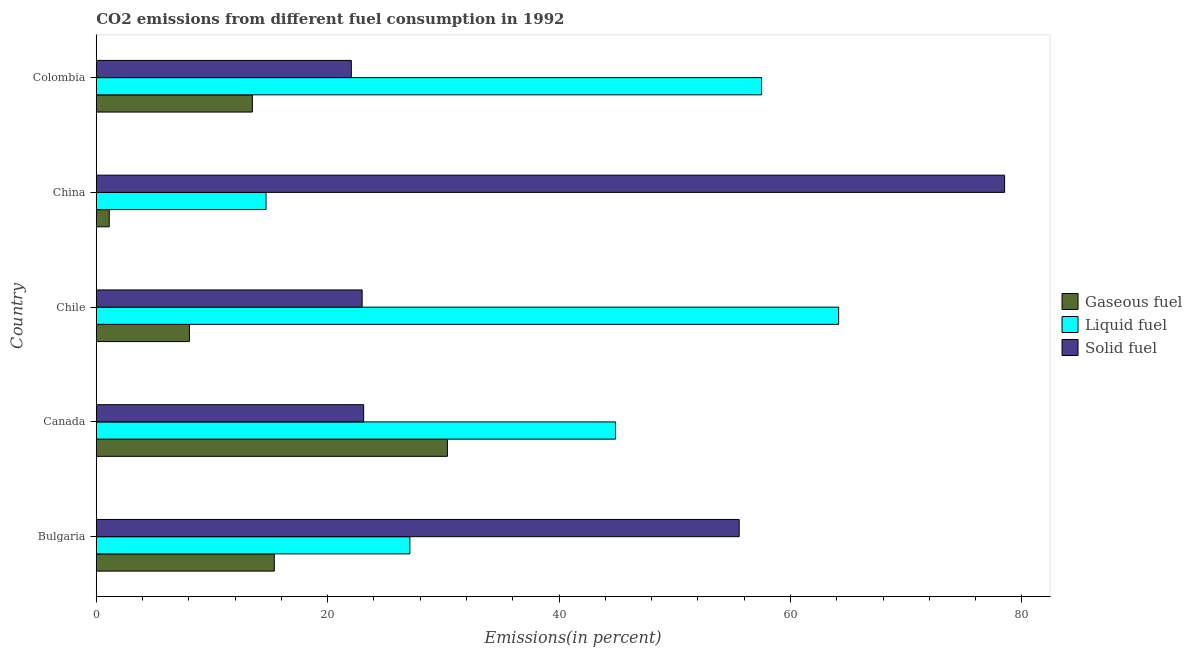How many different coloured bars are there?
Your response must be concise. 3. How many groups of bars are there?
Give a very brief answer. 5. Are the number of bars on each tick of the Y-axis equal?
Provide a succinct answer. Yes. How many bars are there on the 3rd tick from the bottom?
Your answer should be compact. 3. In how many cases, is the number of bars for a given country not equal to the number of legend labels?
Offer a terse response. 0. What is the percentage of liquid fuel emission in Chile?
Make the answer very short. 64.16. Across all countries, what is the maximum percentage of solid fuel emission?
Give a very brief answer. 78.5. Across all countries, what is the minimum percentage of liquid fuel emission?
Provide a succinct answer. 14.67. What is the total percentage of liquid fuel emission in the graph?
Your answer should be very brief. 208.32. What is the difference between the percentage of gaseous fuel emission in Bulgaria and that in Chile?
Make the answer very short. 7.33. What is the difference between the percentage of liquid fuel emission in Colombia and the percentage of solid fuel emission in Canada?
Your response must be concise. 34.39. What is the average percentage of gaseous fuel emission per country?
Provide a short and direct response. 13.68. What is the difference between the percentage of liquid fuel emission and percentage of gaseous fuel emission in China?
Your response must be concise. 13.55. In how many countries, is the percentage of gaseous fuel emission greater than 68 %?
Your answer should be very brief. 0. What is the ratio of the percentage of gaseous fuel emission in Bulgaria to that in Canada?
Provide a short and direct response. 0.51. Is the percentage of gaseous fuel emission in Bulgaria less than that in Canada?
Provide a short and direct response. Yes. Is the difference between the percentage of gaseous fuel emission in Bulgaria and Colombia greater than the difference between the percentage of liquid fuel emission in Bulgaria and Colombia?
Ensure brevity in your answer.  Yes. What is the difference between the highest and the second highest percentage of liquid fuel emission?
Ensure brevity in your answer.  6.66. What is the difference between the highest and the lowest percentage of solid fuel emission?
Provide a succinct answer. 56.46. In how many countries, is the percentage of solid fuel emission greater than the average percentage of solid fuel emission taken over all countries?
Your response must be concise. 2. What does the 1st bar from the top in Chile represents?
Your answer should be very brief. Solid fuel. What does the 2nd bar from the bottom in China represents?
Ensure brevity in your answer.  Liquid fuel. How many bars are there?
Offer a very short reply. 15. Are all the bars in the graph horizontal?
Provide a succinct answer. Yes. How many countries are there in the graph?
Provide a succinct answer. 5. Does the graph contain any zero values?
Make the answer very short. No. Does the graph contain grids?
Provide a succinct answer. No. How are the legend labels stacked?
Your response must be concise. Vertical. What is the title of the graph?
Ensure brevity in your answer.  CO2 emissions from different fuel consumption in 1992. What is the label or title of the X-axis?
Ensure brevity in your answer.  Emissions(in percent). What is the Emissions(in percent) in Gaseous fuel in Bulgaria?
Your answer should be compact. 15.39. What is the Emissions(in percent) of Liquid fuel in Bulgaria?
Make the answer very short. 27.1. What is the Emissions(in percent) of Solid fuel in Bulgaria?
Ensure brevity in your answer.  55.57. What is the Emissions(in percent) in Gaseous fuel in Canada?
Offer a very short reply. 30.35. What is the Emissions(in percent) in Liquid fuel in Canada?
Give a very brief answer. 44.88. What is the Emissions(in percent) of Solid fuel in Canada?
Make the answer very short. 23.11. What is the Emissions(in percent) in Gaseous fuel in Chile?
Provide a short and direct response. 8.05. What is the Emissions(in percent) of Liquid fuel in Chile?
Your answer should be very brief. 64.16. What is the Emissions(in percent) of Solid fuel in Chile?
Offer a very short reply. 22.98. What is the Emissions(in percent) in Gaseous fuel in China?
Give a very brief answer. 1.12. What is the Emissions(in percent) in Liquid fuel in China?
Ensure brevity in your answer.  14.67. What is the Emissions(in percent) of Solid fuel in China?
Make the answer very short. 78.5. What is the Emissions(in percent) in Gaseous fuel in Colombia?
Offer a terse response. 13.49. What is the Emissions(in percent) in Liquid fuel in Colombia?
Give a very brief answer. 57.5. What is the Emissions(in percent) in Solid fuel in Colombia?
Your answer should be very brief. 22.04. Across all countries, what is the maximum Emissions(in percent) of Gaseous fuel?
Your response must be concise. 30.35. Across all countries, what is the maximum Emissions(in percent) in Liquid fuel?
Your response must be concise. 64.16. Across all countries, what is the maximum Emissions(in percent) in Solid fuel?
Your response must be concise. 78.5. Across all countries, what is the minimum Emissions(in percent) of Gaseous fuel?
Your response must be concise. 1.12. Across all countries, what is the minimum Emissions(in percent) of Liquid fuel?
Offer a very short reply. 14.67. Across all countries, what is the minimum Emissions(in percent) in Solid fuel?
Your answer should be compact. 22.04. What is the total Emissions(in percent) in Gaseous fuel in the graph?
Your answer should be very brief. 68.4. What is the total Emissions(in percent) in Liquid fuel in the graph?
Ensure brevity in your answer.  208.32. What is the total Emissions(in percent) of Solid fuel in the graph?
Your answer should be compact. 202.2. What is the difference between the Emissions(in percent) in Gaseous fuel in Bulgaria and that in Canada?
Give a very brief answer. -14.96. What is the difference between the Emissions(in percent) in Liquid fuel in Bulgaria and that in Canada?
Your answer should be very brief. -17.78. What is the difference between the Emissions(in percent) in Solid fuel in Bulgaria and that in Canada?
Your answer should be very brief. 32.46. What is the difference between the Emissions(in percent) of Gaseous fuel in Bulgaria and that in Chile?
Offer a very short reply. 7.34. What is the difference between the Emissions(in percent) in Liquid fuel in Bulgaria and that in Chile?
Your answer should be compact. -37.06. What is the difference between the Emissions(in percent) of Solid fuel in Bulgaria and that in Chile?
Keep it short and to the point. 32.59. What is the difference between the Emissions(in percent) in Gaseous fuel in Bulgaria and that in China?
Offer a terse response. 14.26. What is the difference between the Emissions(in percent) of Liquid fuel in Bulgaria and that in China?
Provide a short and direct response. 12.43. What is the difference between the Emissions(in percent) in Solid fuel in Bulgaria and that in China?
Give a very brief answer. -22.94. What is the difference between the Emissions(in percent) of Gaseous fuel in Bulgaria and that in Colombia?
Give a very brief answer. 1.89. What is the difference between the Emissions(in percent) of Liquid fuel in Bulgaria and that in Colombia?
Provide a short and direct response. -30.4. What is the difference between the Emissions(in percent) in Solid fuel in Bulgaria and that in Colombia?
Give a very brief answer. 33.52. What is the difference between the Emissions(in percent) in Gaseous fuel in Canada and that in Chile?
Keep it short and to the point. 22.3. What is the difference between the Emissions(in percent) of Liquid fuel in Canada and that in Chile?
Your answer should be very brief. -19.28. What is the difference between the Emissions(in percent) in Solid fuel in Canada and that in Chile?
Offer a terse response. 0.13. What is the difference between the Emissions(in percent) in Gaseous fuel in Canada and that in China?
Your answer should be very brief. 29.23. What is the difference between the Emissions(in percent) of Liquid fuel in Canada and that in China?
Provide a short and direct response. 30.21. What is the difference between the Emissions(in percent) in Solid fuel in Canada and that in China?
Make the answer very short. -55.39. What is the difference between the Emissions(in percent) in Gaseous fuel in Canada and that in Colombia?
Your answer should be very brief. 16.86. What is the difference between the Emissions(in percent) in Liquid fuel in Canada and that in Colombia?
Your response must be concise. -12.62. What is the difference between the Emissions(in percent) of Solid fuel in Canada and that in Colombia?
Keep it short and to the point. 1.07. What is the difference between the Emissions(in percent) of Gaseous fuel in Chile and that in China?
Your answer should be very brief. 6.93. What is the difference between the Emissions(in percent) of Liquid fuel in Chile and that in China?
Provide a short and direct response. 49.49. What is the difference between the Emissions(in percent) of Solid fuel in Chile and that in China?
Your response must be concise. -55.53. What is the difference between the Emissions(in percent) of Gaseous fuel in Chile and that in Colombia?
Provide a succinct answer. -5.44. What is the difference between the Emissions(in percent) in Liquid fuel in Chile and that in Colombia?
Provide a short and direct response. 6.66. What is the difference between the Emissions(in percent) in Solid fuel in Chile and that in Colombia?
Provide a succinct answer. 0.94. What is the difference between the Emissions(in percent) of Gaseous fuel in China and that in Colombia?
Offer a terse response. -12.37. What is the difference between the Emissions(in percent) in Liquid fuel in China and that in Colombia?
Make the answer very short. -42.83. What is the difference between the Emissions(in percent) in Solid fuel in China and that in Colombia?
Ensure brevity in your answer.  56.46. What is the difference between the Emissions(in percent) of Gaseous fuel in Bulgaria and the Emissions(in percent) of Liquid fuel in Canada?
Give a very brief answer. -29.5. What is the difference between the Emissions(in percent) of Gaseous fuel in Bulgaria and the Emissions(in percent) of Solid fuel in Canada?
Offer a very short reply. -7.72. What is the difference between the Emissions(in percent) of Liquid fuel in Bulgaria and the Emissions(in percent) of Solid fuel in Canada?
Ensure brevity in your answer.  3.99. What is the difference between the Emissions(in percent) in Gaseous fuel in Bulgaria and the Emissions(in percent) in Liquid fuel in Chile?
Give a very brief answer. -48.77. What is the difference between the Emissions(in percent) in Gaseous fuel in Bulgaria and the Emissions(in percent) in Solid fuel in Chile?
Make the answer very short. -7.59. What is the difference between the Emissions(in percent) of Liquid fuel in Bulgaria and the Emissions(in percent) of Solid fuel in Chile?
Provide a succinct answer. 4.12. What is the difference between the Emissions(in percent) of Gaseous fuel in Bulgaria and the Emissions(in percent) of Liquid fuel in China?
Offer a terse response. 0.71. What is the difference between the Emissions(in percent) of Gaseous fuel in Bulgaria and the Emissions(in percent) of Solid fuel in China?
Offer a very short reply. -63.12. What is the difference between the Emissions(in percent) of Liquid fuel in Bulgaria and the Emissions(in percent) of Solid fuel in China?
Offer a terse response. -51.4. What is the difference between the Emissions(in percent) of Gaseous fuel in Bulgaria and the Emissions(in percent) of Liquid fuel in Colombia?
Your answer should be very brief. -42.12. What is the difference between the Emissions(in percent) in Gaseous fuel in Bulgaria and the Emissions(in percent) in Solid fuel in Colombia?
Offer a very short reply. -6.66. What is the difference between the Emissions(in percent) in Liquid fuel in Bulgaria and the Emissions(in percent) in Solid fuel in Colombia?
Provide a succinct answer. 5.06. What is the difference between the Emissions(in percent) in Gaseous fuel in Canada and the Emissions(in percent) in Liquid fuel in Chile?
Your answer should be very brief. -33.81. What is the difference between the Emissions(in percent) in Gaseous fuel in Canada and the Emissions(in percent) in Solid fuel in Chile?
Offer a very short reply. 7.37. What is the difference between the Emissions(in percent) of Liquid fuel in Canada and the Emissions(in percent) of Solid fuel in Chile?
Keep it short and to the point. 21.9. What is the difference between the Emissions(in percent) in Gaseous fuel in Canada and the Emissions(in percent) in Liquid fuel in China?
Provide a short and direct response. 15.68. What is the difference between the Emissions(in percent) in Gaseous fuel in Canada and the Emissions(in percent) in Solid fuel in China?
Keep it short and to the point. -48.16. What is the difference between the Emissions(in percent) of Liquid fuel in Canada and the Emissions(in percent) of Solid fuel in China?
Your answer should be compact. -33.62. What is the difference between the Emissions(in percent) in Gaseous fuel in Canada and the Emissions(in percent) in Liquid fuel in Colombia?
Offer a terse response. -27.15. What is the difference between the Emissions(in percent) in Gaseous fuel in Canada and the Emissions(in percent) in Solid fuel in Colombia?
Keep it short and to the point. 8.3. What is the difference between the Emissions(in percent) in Liquid fuel in Canada and the Emissions(in percent) in Solid fuel in Colombia?
Ensure brevity in your answer.  22.84. What is the difference between the Emissions(in percent) of Gaseous fuel in Chile and the Emissions(in percent) of Liquid fuel in China?
Keep it short and to the point. -6.62. What is the difference between the Emissions(in percent) of Gaseous fuel in Chile and the Emissions(in percent) of Solid fuel in China?
Your answer should be very brief. -70.45. What is the difference between the Emissions(in percent) in Liquid fuel in Chile and the Emissions(in percent) in Solid fuel in China?
Provide a succinct answer. -14.34. What is the difference between the Emissions(in percent) in Gaseous fuel in Chile and the Emissions(in percent) in Liquid fuel in Colombia?
Your answer should be compact. -49.45. What is the difference between the Emissions(in percent) in Gaseous fuel in Chile and the Emissions(in percent) in Solid fuel in Colombia?
Give a very brief answer. -13.99. What is the difference between the Emissions(in percent) of Liquid fuel in Chile and the Emissions(in percent) of Solid fuel in Colombia?
Your response must be concise. 42.12. What is the difference between the Emissions(in percent) in Gaseous fuel in China and the Emissions(in percent) in Liquid fuel in Colombia?
Ensure brevity in your answer.  -56.38. What is the difference between the Emissions(in percent) of Gaseous fuel in China and the Emissions(in percent) of Solid fuel in Colombia?
Ensure brevity in your answer.  -20.92. What is the difference between the Emissions(in percent) in Liquid fuel in China and the Emissions(in percent) in Solid fuel in Colombia?
Provide a short and direct response. -7.37. What is the average Emissions(in percent) of Gaseous fuel per country?
Offer a terse response. 13.68. What is the average Emissions(in percent) of Liquid fuel per country?
Offer a very short reply. 41.66. What is the average Emissions(in percent) in Solid fuel per country?
Ensure brevity in your answer.  40.44. What is the difference between the Emissions(in percent) of Gaseous fuel and Emissions(in percent) of Liquid fuel in Bulgaria?
Provide a succinct answer. -11.72. What is the difference between the Emissions(in percent) of Gaseous fuel and Emissions(in percent) of Solid fuel in Bulgaria?
Offer a very short reply. -40.18. What is the difference between the Emissions(in percent) of Liquid fuel and Emissions(in percent) of Solid fuel in Bulgaria?
Provide a short and direct response. -28.46. What is the difference between the Emissions(in percent) of Gaseous fuel and Emissions(in percent) of Liquid fuel in Canada?
Provide a short and direct response. -14.54. What is the difference between the Emissions(in percent) in Gaseous fuel and Emissions(in percent) in Solid fuel in Canada?
Provide a succinct answer. 7.24. What is the difference between the Emissions(in percent) in Liquid fuel and Emissions(in percent) in Solid fuel in Canada?
Offer a terse response. 21.77. What is the difference between the Emissions(in percent) in Gaseous fuel and Emissions(in percent) in Liquid fuel in Chile?
Your answer should be compact. -56.11. What is the difference between the Emissions(in percent) of Gaseous fuel and Emissions(in percent) of Solid fuel in Chile?
Your response must be concise. -14.93. What is the difference between the Emissions(in percent) of Liquid fuel and Emissions(in percent) of Solid fuel in Chile?
Make the answer very short. 41.18. What is the difference between the Emissions(in percent) in Gaseous fuel and Emissions(in percent) in Liquid fuel in China?
Provide a short and direct response. -13.55. What is the difference between the Emissions(in percent) of Gaseous fuel and Emissions(in percent) of Solid fuel in China?
Your response must be concise. -77.38. What is the difference between the Emissions(in percent) in Liquid fuel and Emissions(in percent) in Solid fuel in China?
Provide a succinct answer. -63.83. What is the difference between the Emissions(in percent) of Gaseous fuel and Emissions(in percent) of Liquid fuel in Colombia?
Keep it short and to the point. -44.01. What is the difference between the Emissions(in percent) of Gaseous fuel and Emissions(in percent) of Solid fuel in Colombia?
Ensure brevity in your answer.  -8.55. What is the difference between the Emissions(in percent) of Liquid fuel and Emissions(in percent) of Solid fuel in Colombia?
Give a very brief answer. 35.46. What is the ratio of the Emissions(in percent) in Gaseous fuel in Bulgaria to that in Canada?
Give a very brief answer. 0.51. What is the ratio of the Emissions(in percent) in Liquid fuel in Bulgaria to that in Canada?
Your answer should be very brief. 0.6. What is the ratio of the Emissions(in percent) of Solid fuel in Bulgaria to that in Canada?
Your answer should be very brief. 2.4. What is the ratio of the Emissions(in percent) of Gaseous fuel in Bulgaria to that in Chile?
Give a very brief answer. 1.91. What is the ratio of the Emissions(in percent) of Liquid fuel in Bulgaria to that in Chile?
Provide a succinct answer. 0.42. What is the ratio of the Emissions(in percent) of Solid fuel in Bulgaria to that in Chile?
Ensure brevity in your answer.  2.42. What is the ratio of the Emissions(in percent) in Gaseous fuel in Bulgaria to that in China?
Offer a terse response. 13.71. What is the ratio of the Emissions(in percent) in Liquid fuel in Bulgaria to that in China?
Provide a short and direct response. 1.85. What is the ratio of the Emissions(in percent) in Solid fuel in Bulgaria to that in China?
Make the answer very short. 0.71. What is the ratio of the Emissions(in percent) in Gaseous fuel in Bulgaria to that in Colombia?
Ensure brevity in your answer.  1.14. What is the ratio of the Emissions(in percent) in Liquid fuel in Bulgaria to that in Colombia?
Provide a short and direct response. 0.47. What is the ratio of the Emissions(in percent) of Solid fuel in Bulgaria to that in Colombia?
Offer a terse response. 2.52. What is the ratio of the Emissions(in percent) in Gaseous fuel in Canada to that in Chile?
Your answer should be compact. 3.77. What is the ratio of the Emissions(in percent) in Liquid fuel in Canada to that in Chile?
Your answer should be compact. 0.7. What is the ratio of the Emissions(in percent) of Gaseous fuel in Canada to that in China?
Ensure brevity in your answer.  27.04. What is the ratio of the Emissions(in percent) in Liquid fuel in Canada to that in China?
Keep it short and to the point. 3.06. What is the ratio of the Emissions(in percent) in Solid fuel in Canada to that in China?
Your answer should be very brief. 0.29. What is the ratio of the Emissions(in percent) in Gaseous fuel in Canada to that in Colombia?
Offer a terse response. 2.25. What is the ratio of the Emissions(in percent) of Liquid fuel in Canada to that in Colombia?
Make the answer very short. 0.78. What is the ratio of the Emissions(in percent) in Solid fuel in Canada to that in Colombia?
Your answer should be very brief. 1.05. What is the ratio of the Emissions(in percent) in Gaseous fuel in Chile to that in China?
Your answer should be compact. 7.17. What is the ratio of the Emissions(in percent) in Liquid fuel in Chile to that in China?
Your answer should be compact. 4.37. What is the ratio of the Emissions(in percent) in Solid fuel in Chile to that in China?
Your answer should be compact. 0.29. What is the ratio of the Emissions(in percent) of Gaseous fuel in Chile to that in Colombia?
Your response must be concise. 0.6. What is the ratio of the Emissions(in percent) in Liquid fuel in Chile to that in Colombia?
Give a very brief answer. 1.12. What is the ratio of the Emissions(in percent) of Solid fuel in Chile to that in Colombia?
Your answer should be very brief. 1.04. What is the ratio of the Emissions(in percent) of Gaseous fuel in China to that in Colombia?
Offer a terse response. 0.08. What is the ratio of the Emissions(in percent) in Liquid fuel in China to that in Colombia?
Provide a succinct answer. 0.26. What is the ratio of the Emissions(in percent) in Solid fuel in China to that in Colombia?
Offer a terse response. 3.56. What is the difference between the highest and the second highest Emissions(in percent) of Gaseous fuel?
Give a very brief answer. 14.96. What is the difference between the highest and the second highest Emissions(in percent) of Liquid fuel?
Your response must be concise. 6.66. What is the difference between the highest and the second highest Emissions(in percent) of Solid fuel?
Make the answer very short. 22.94. What is the difference between the highest and the lowest Emissions(in percent) of Gaseous fuel?
Your response must be concise. 29.23. What is the difference between the highest and the lowest Emissions(in percent) in Liquid fuel?
Provide a short and direct response. 49.49. What is the difference between the highest and the lowest Emissions(in percent) of Solid fuel?
Make the answer very short. 56.46. 